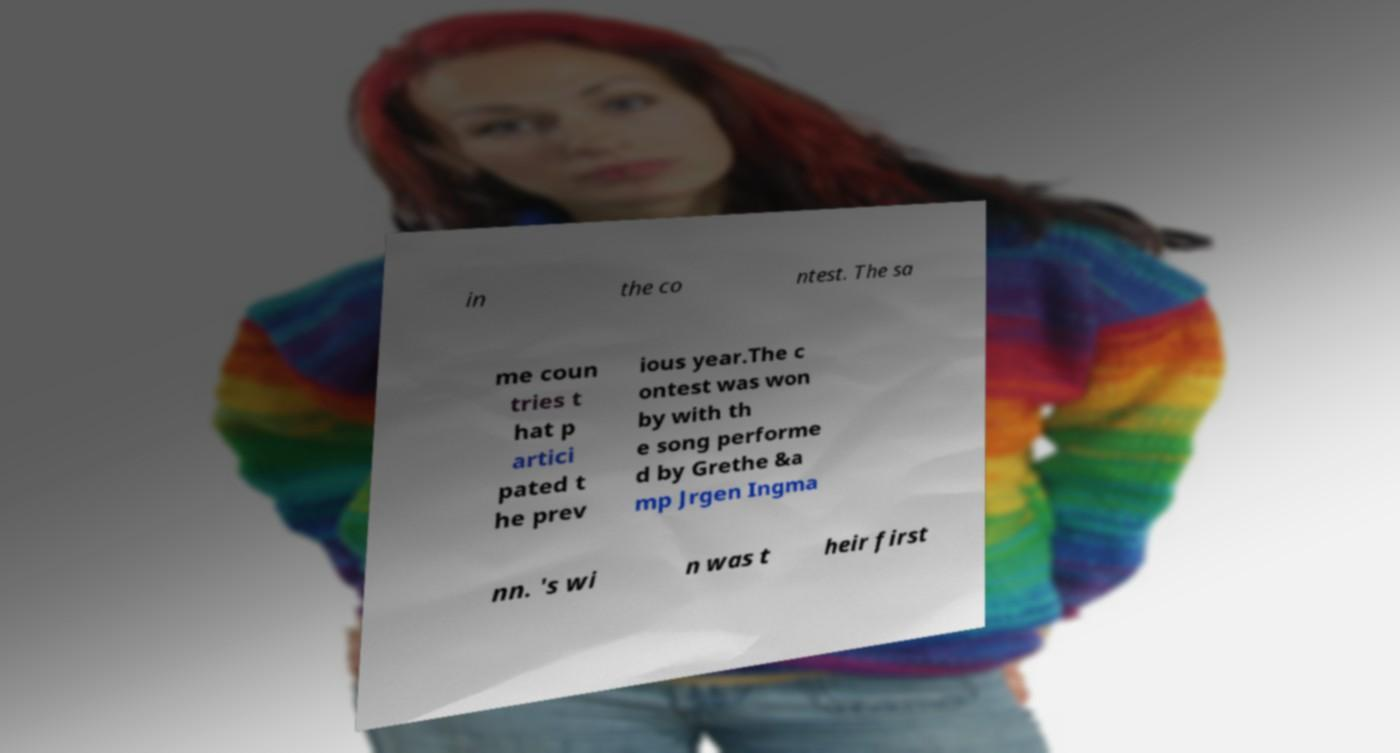Could you assist in decoding the text presented in this image and type it out clearly? in the co ntest. The sa me coun tries t hat p artici pated t he prev ious year.The c ontest was won by with th e song performe d by Grethe &a mp Jrgen Ingma nn. 's wi n was t heir first 